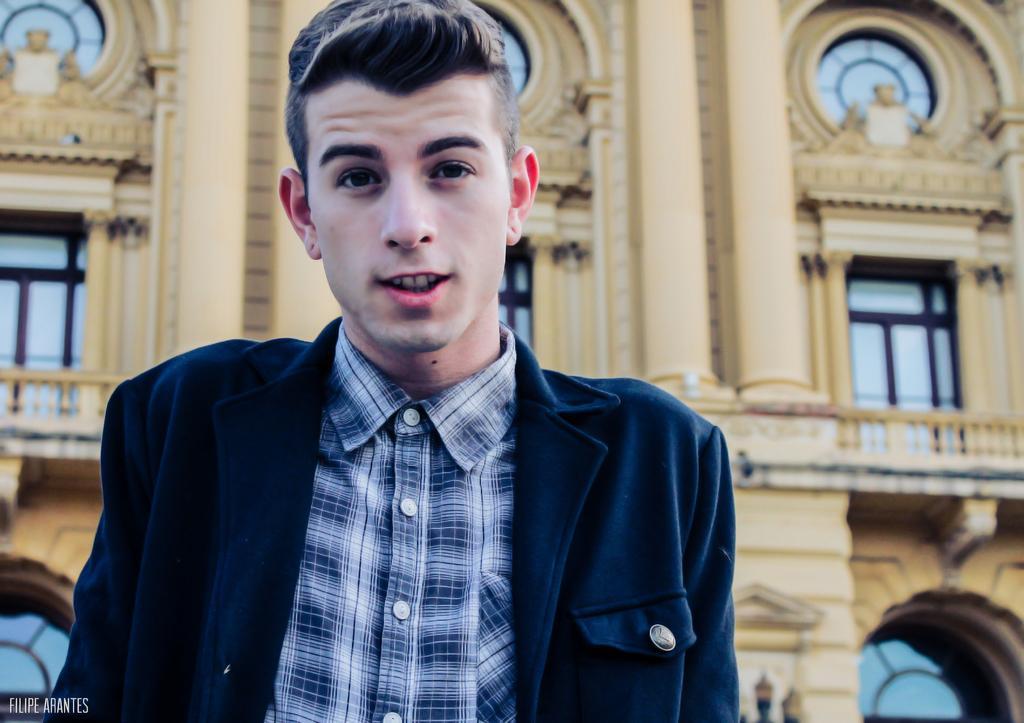Describe this image in one or two sentences. In this image there is a man, he is wearing shirt and coat, in the background there is building, in the bottom left there is text. 